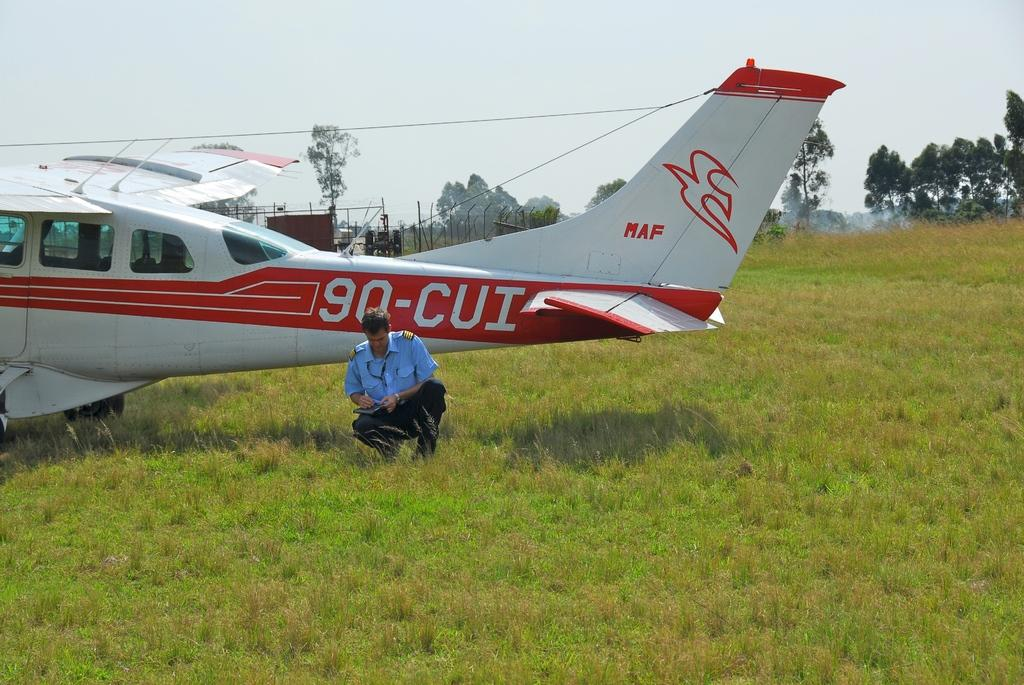<image>
Create a compact narrative representing the image presented. A single engine plane with tail number 90-CUI 